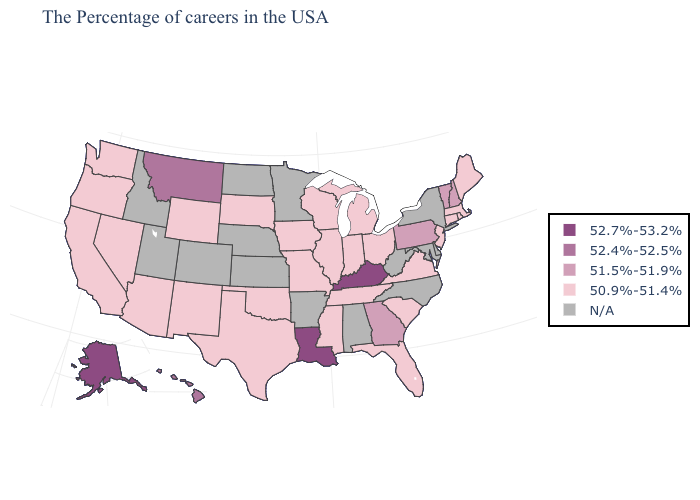What is the value of Minnesota?
Quick response, please. N/A. What is the value of Kentucky?
Answer briefly. 52.7%-53.2%. Does Vermont have the lowest value in the USA?
Short answer required. No. What is the value of New Hampshire?
Quick response, please. 51.5%-51.9%. What is the value of West Virginia?
Keep it brief. N/A. What is the value of Florida?
Give a very brief answer. 50.9%-51.4%. What is the highest value in states that border Arizona?
Write a very short answer. 50.9%-51.4%. Name the states that have a value in the range 50.9%-51.4%?
Quick response, please. Maine, Massachusetts, Rhode Island, Connecticut, New Jersey, Virginia, South Carolina, Ohio, Florida, Michigan, Indiana, Tennessee, Wisconsin, Illinois, Mississippi, Missouri, Iowa, Oklahoma, Texas, South Dakota, Wyoming, New Mexico, Arizona, Nevada, California, Washington, Oregon. Does the map have missing data?
Give a very brief answer. Yes. Name the states that have a value in the range 52.4%-52.5%?
Be succinct. Montana, Hawaii. Name the states that have a value in the range 52.7%-53.2%?
Concise answer only. Kentucky, Louisiana, Alaska. Which states hav the highest value in the West?
Concise answer only. Alaska. Which states have the highest value in the USA?
Give a very brief answer. Kentucky, Louisiana, Alaska. 